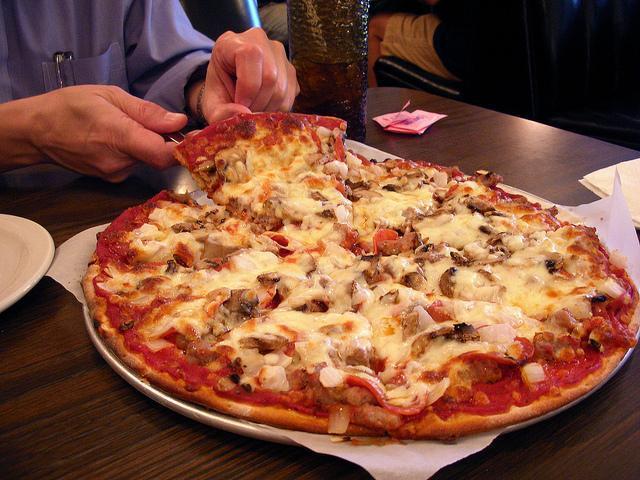How many pizzas can you see?
Give a very brief answer. 1. How many people can you see?
Give a very brief answer. 2. How many train cars are orange?
Give a very brief answer. 0. 